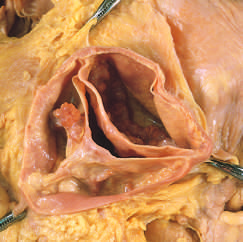one cusp has a partial fusion at whose center?
Answer the question using a single word or phrase. Its 